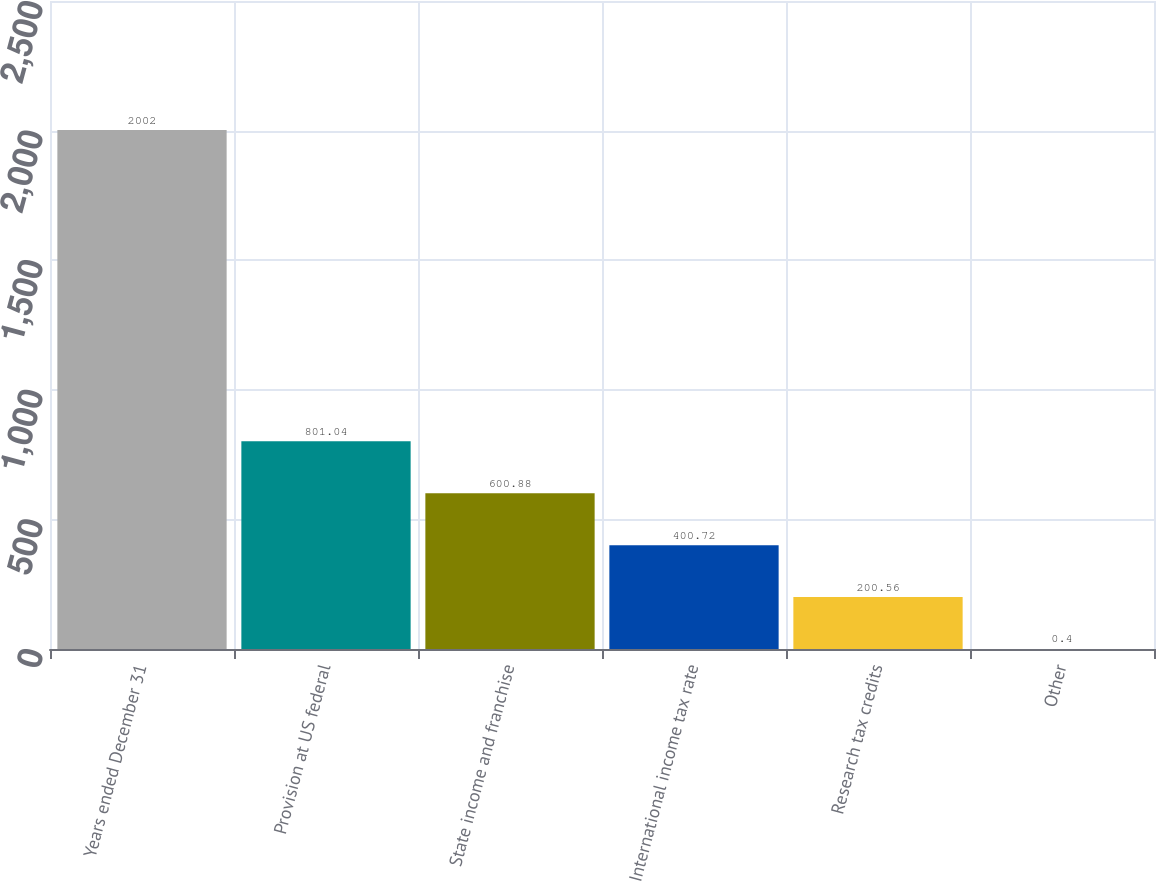Convert chart to OTSL. <chart><loc_0><loc_0><loc_500><loc_500><bar_chart><fcel>Years ended December 31<fcel>Provision at US federal<fcel>State income and franchise<fcel>International income tax rate<fcel>Research tax credits<fcel>Other<nl><fcel>2002<fcel>801.04<fcel>600.88<fcel>400.72<fcel>200.56<fcel>0.4<nl></chart> 